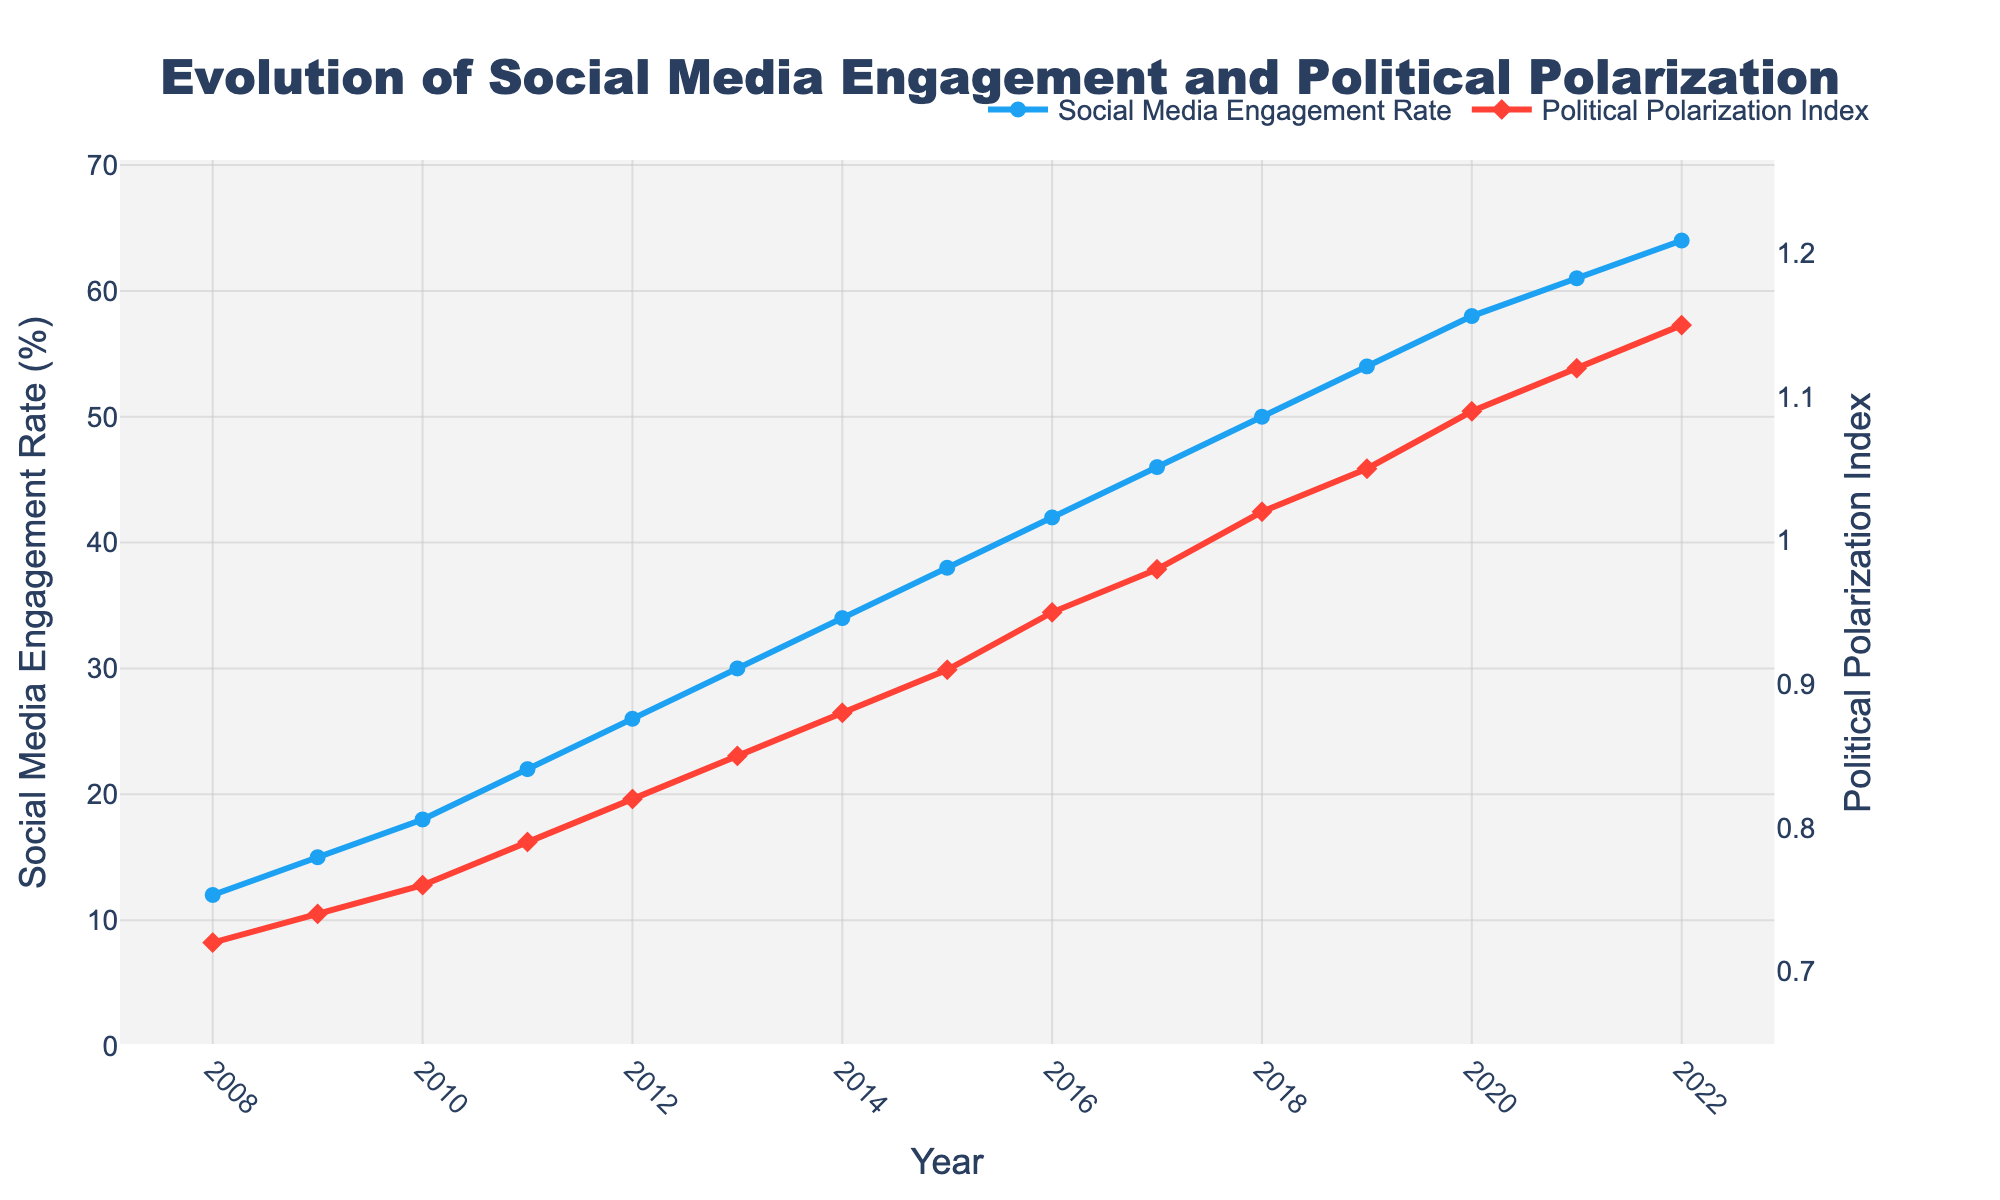What is the general trend of social media engagement rates from 2008 to 2022? The line representing social media engagement rates generally increases from 2008 to 2022, indicating a continuous rise in engagement over these years.
Answer: Continuous increase In which year did the social media engagement rate reach 50%? Locate the intersection of the social media engagement rate line and the 50% mark on the vertical axis, then trace vertically down to the corresponding year on the horizontal axis. This intersection occurs in 2018.
Answer: 2018 How did the political polarization index change from 2016 to 2017? Identify the data points for the political polarization index in 2016 and 2017. The index increased from 0.95 in 2016 to 0.98 in 2017.
Answer: Increased by 0.03 What is the percentage point difference in social media engagement rates between 2008 and 2022? Subtract the social media engagement rate in 2008 (12%) from the rate in 2022 (64%). The difference is 64% - 12% = 52%.
Answer: 52% Between which consecutive years did the political polarization index experience the largest increase? Examine the changes in the political polarization index year by year and compare the differences. The largest increase is between 2019 (1.05) and 2020 (1.09); the difference is 0.04.
Answer: 2019-2020 How does the color coding in the chart help distinguish between the social media engagement rate and the political polarization index? The social media engagement rate line is blue and the political polarization index line is red. These distinct colors help easily differentiate between the two metrics visually.
Answer: Blue and red What is the average annual increase in social media engagement rates from 2008 to 2022? First, find the total increase in social media engagement rates from 2008 to 2022, which is 64% - 12% = 52%. Then, divide this total increase by the number of years (2022 - 2008 = 14 years). The average annual increase is 52% / 14 ≈ 3.71%.
Answer: 3.71% Which year had the highest political polarization index? Locate the peak value of the political polarization index on the graph, which is 1.15. Trace down to the corresponding year, which is 2022.
Answer: 2022 Is there a year when both social media engagement rates and political polarization index increased simultaneously? Examine the graph to see if both metrics rise together in any year. Both the social media engagement rates and political polarization index increase every year from 2008 to 2022.
Answer: Yes, every year What can be inferred about the relationship between social media engagement rates and political polarization index from 2008 to 2022? Both lines show a general upward trend over the years, suggesting a potential positive correlation between increased social media engagement and rising political polarization.
Answer: Positive correlation 